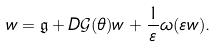<formula> <loc_0><loc_0><loc_500><loc_500>w = \mathfrak { g } + D \mathcal { G } ( \theta ) w + \frac { 1 } { \varepsilon } \omega ( \varepsilon w ) .</formula> 